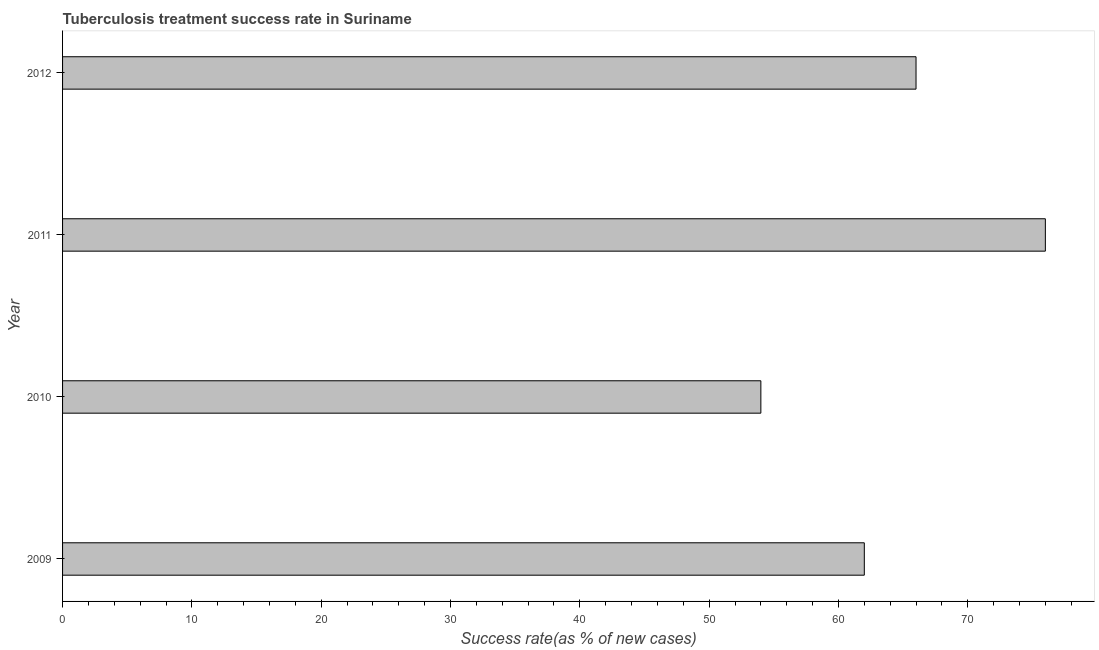Does the graph contain any zero values?
Provide a succinct answer. No. What is the title of the graph?
Keep it short and to the point. Tuberculosis treatment success rate in Suriname. What is the label or title of the X-axis?
Your answer should be very brief. Success rate(as % of new cases). Across all years, what is the maximum tuberculosis treatment success rate?
Ensure brevity in your answer.  76. In which year was the tuberculosis treatment success rate maximum?
Your answer should be compact. 2011. In which year was the tuberculosis treatment success rate minimum?
Your response must be concise. 2010. What is the sum of the tuberculosis treatment success rate?
Ensure brevity in your answer.  258. What is the difference between the tuberculosis treatment success rate in 2009 and 2010?
Provide a short and direct response. 8. What is the median tuberculosis treatment success rate?
Provide a succinct answer. 64. In how many years, is the tuberculosis treatment success rate greater than 48 %?
Provide a short and direct response. 4. Do a majority of the years between 2010 and 2012 (inclusive) have tuberculosis treatment success rate greater than 14 %?
Your answer should be very brief. Yes. What is the ratio of the tuberculosis treatment success rate in 2010 to that in 2012?
Provide a succinct answer. 0.82. Is the tuberculosis treatment success rate in 2010 less than that in 2011?
Your response must be concise. Yes. Is the difference between the tuberculosis treatment success rate in 2011 and 2012 greater than the difference between any two years?
Provide a succinct answer. No. What is the difference between the highest and the second highest tuberculosis treatment success rate?
Keep it short and to the point. 10. Is the sum of the tuberculosis treatment success rate in 2010 and 2011 greater than the maximum tuberculosis treatment success rate across all years?
Your response must be concise. Yes. In how many years, is the tuberculosis treatment success rate greater than the average tuberculosis treatment success rate taken over all years?
Provide a short and direct response. 2. How many years are there in the graph?
Make the answer very short. 4. What is the Success rate(as % of new cases) in 2011?
Your answer should be compact. 76. What is the ratio of the Success rate(as % of new cases) in 2009 to that in 2010?
Your answer should be compact. 1.15. What is the ratio of the Success rate(as % of new cases) in 2009 to that in 2011?
Offer a very short reply. 0.82. What is the ratio of the Success rate(as % of new cases) in 2009 to that in 2012?
Make the answer very short. 0.94. What is the ratio of the Success rate(as % of new cases) in 2010 to that in 2011?
Make the answer very short. 0.71. What is the ratio of the Success rate(as % of new cases) in 2010 to that in 2012?
Offer a very short reply. 0.82. What is the ratio of the Success rate(as % of new cases) in 2011 to that in 2012?
Your answer should be very brief. 1.15. 